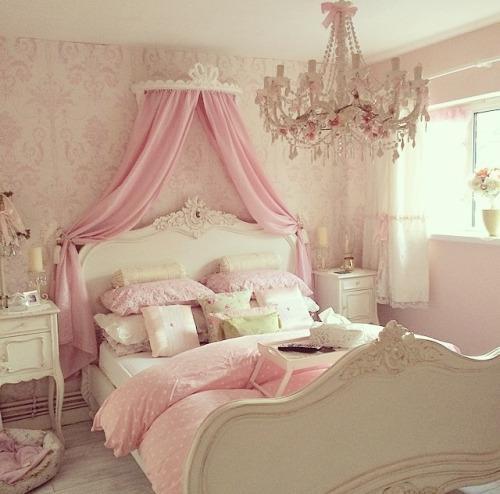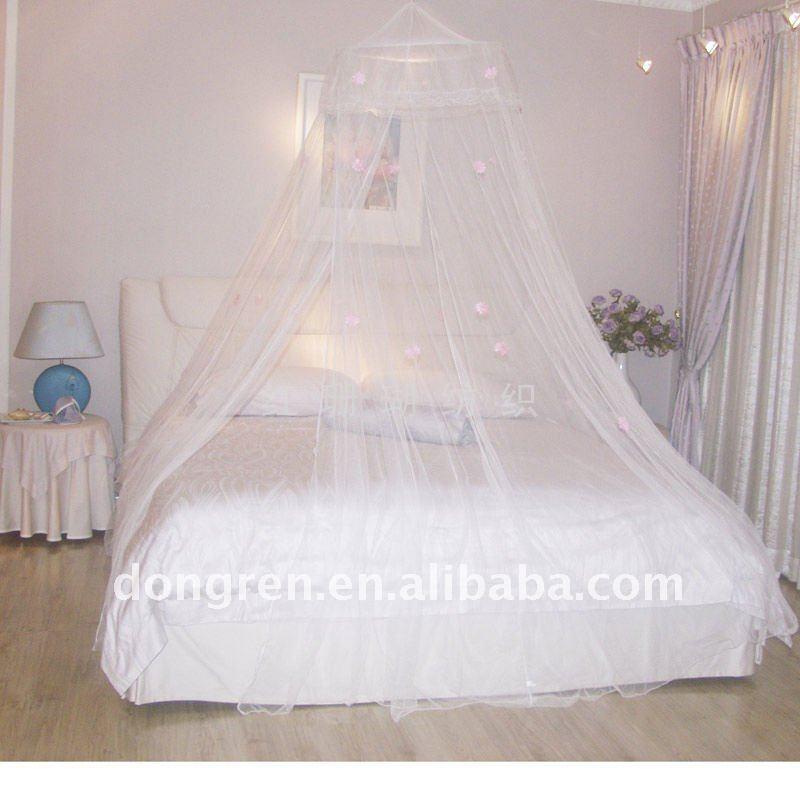The first image is the image on the left, the second image is the image on the right. Given the left and right images, does the statement "The left and right image contains a total of two pink canopies." hold true? Answer yes or no. No. The first image is the image on the left, the second image is the image on the right. Given the left and right images, does the statement "All the bed nets are pink." hold true? Answer yes or no. No. 